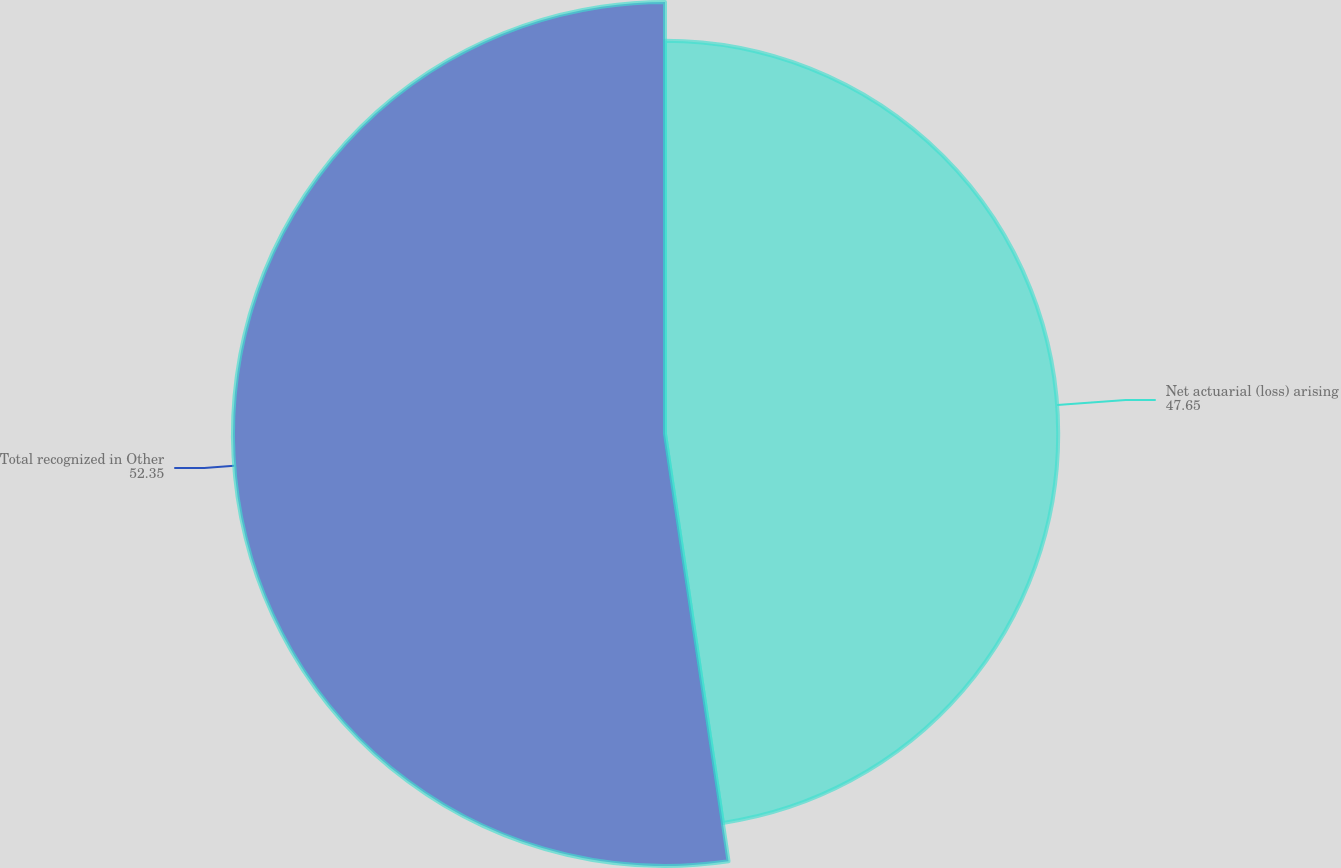Convert chart to OTSL. <chart><loc_0><loc_0><loc_500><loc_500><pie_chart><fcel>Net actuarial (loss) arising<fcel>Total recognized in Other<nl><fcel>47.65%<fcel>52.35%<nl></chart> 